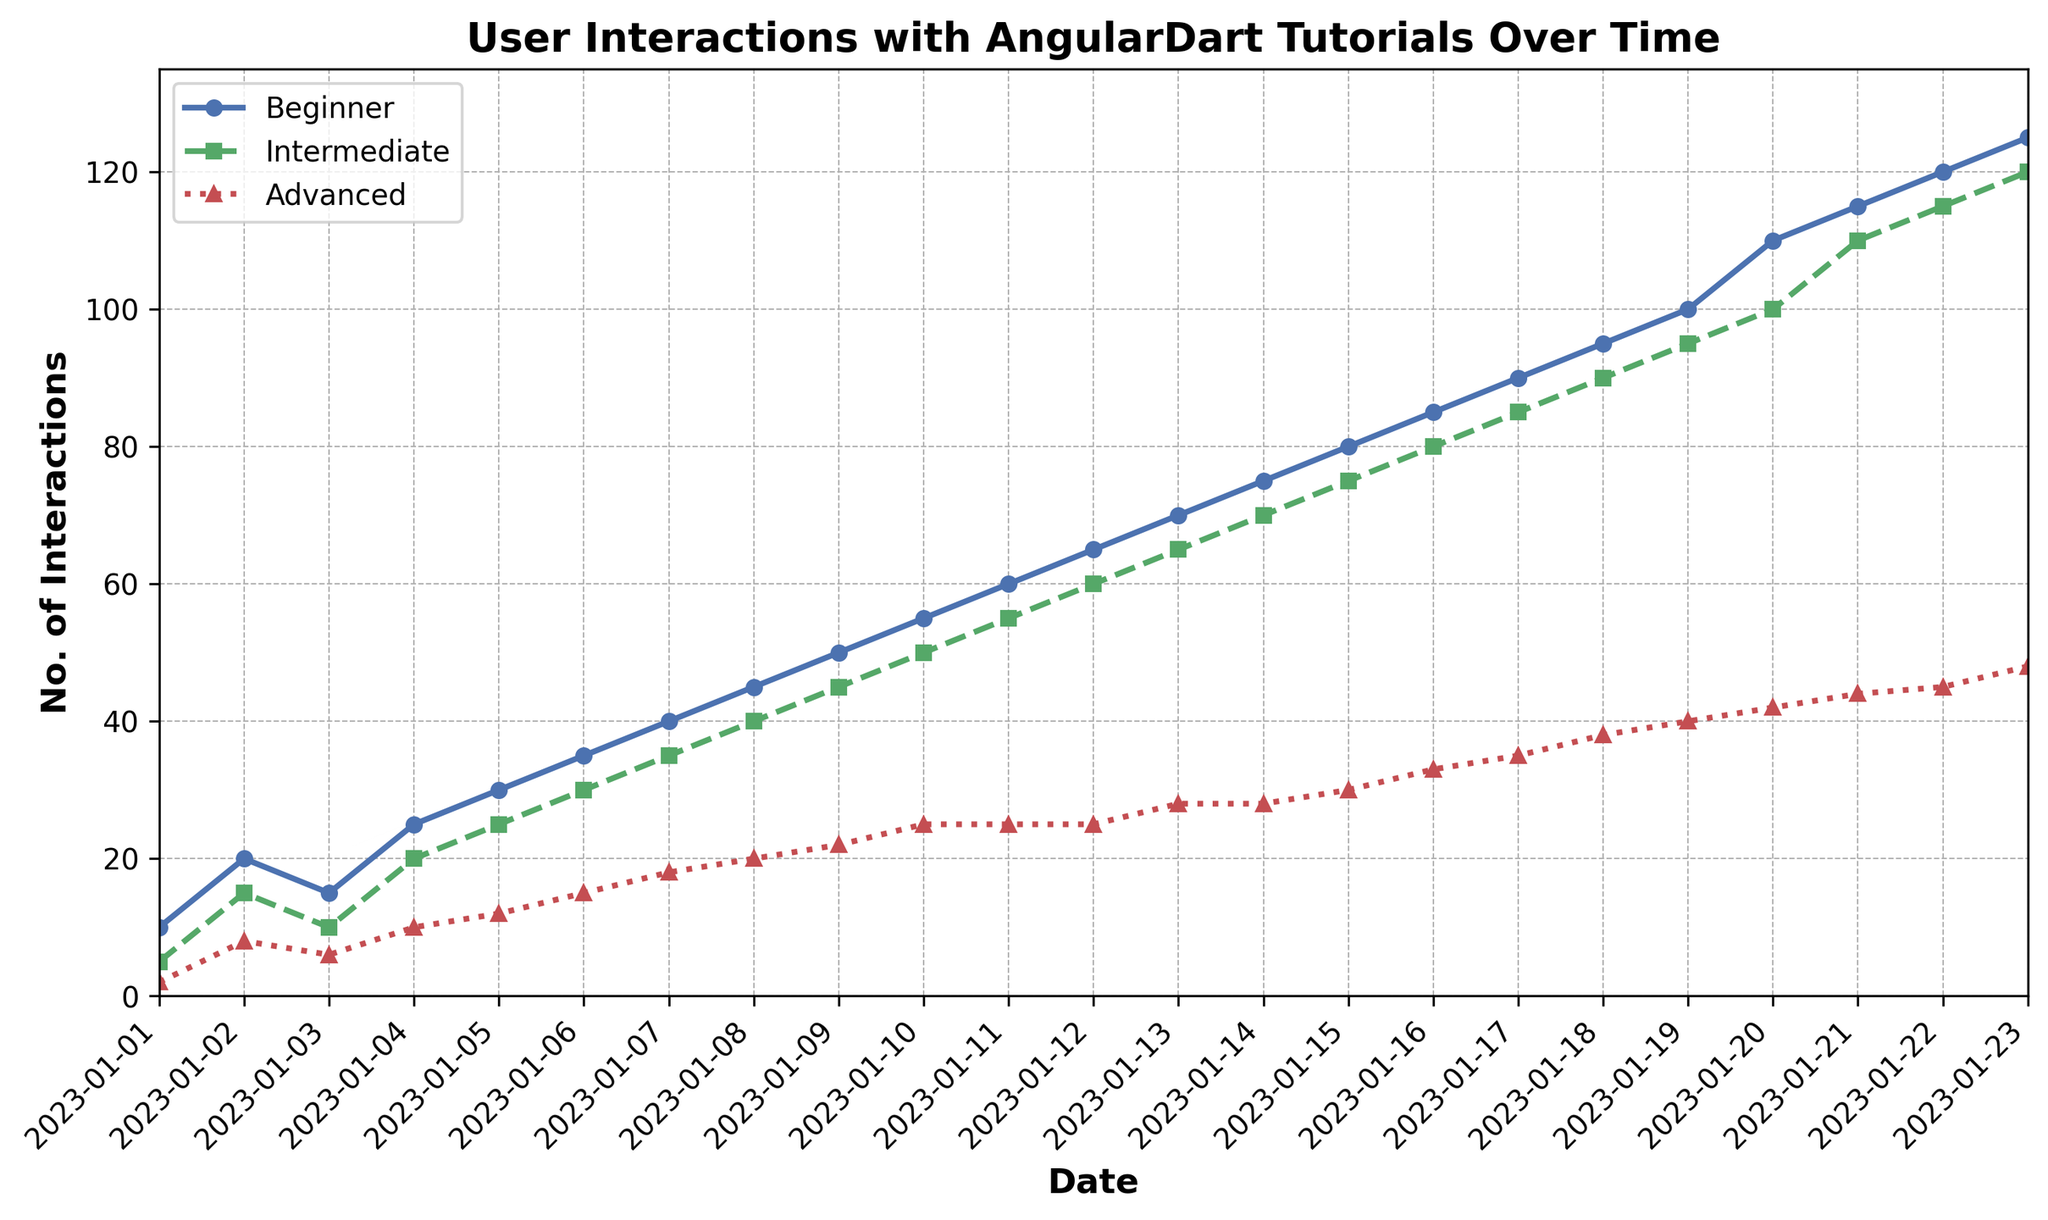What was the number of beginner interactions on January 10 compared to advanced interactions on the same day? On January 10, the chart shows that beginner interactions are represented by the blue line, and the value is 55. Advanced interactions are represented by the red line, and the value is 25. Therefore, beginner interactions are higher on this day.
Answer: Beginner interactions were higher than advanced interactions by 30 What is the total number of interactions for intermediate tutorials from January 1 to January 10? Sum the values of intermediate interactions from January 1 to January 10: 5 + 15 + 10 + 20 + 25 + 30 + 35 + 40 + 45 + 50 = 275.
Answer: 275 Which day has the highest increase in advanced interactions compared to the previous day? Analyze the difference in advanced interactions from one day to the next. The values and differences are as follows: 2→8 (+6), 8→6 (-2), 6→10 (+4), 10→12 (+2), 12→15 (+3), 15→18 (+3), 18→20 (+2), 20→22 (+2), 22→25 (+3), 25→25 (0), 25→25 (0), 25→28 (+3), 28→28 (0), 28→30 (+2), 30→33 (+3), 33→35 (+2), 35→38 (+3), 38→40 (+2), 40→42 (+2), 42→44 (+2), 44→45 (+1), 45→48 (+3). The highest increase is between January 1 and January 2 (+6).
Answer: January 2 What is the average number of beginner interactions over the entire period? First, sum the beginner interactions: (10 + 20 + 15 + 25 + 30 + 35 + 40 + 45 + 50 + 55 + 60 + 65 + 70 + 75 + 80 + 85 + 90 + 95 + 100 + 110 + 115 + 120 + 125) = 1470. Then, divide this sum by the number of days (23). 1470 / 23 ≈ 63.91.
Answer: 63.91 By how much did the number of beginner interactions surpass intermediate interactions on January 18? On January 18, beginner interactions = 95, intermediate interactions = 90. The difference is 95 - 90 = 5.
Answer: 5 On which day did the number of advanced interactions first reach 30, and what were the beginner interactions on that day? The chart shows advanced interactions reach 30 on January 15. On that day, the beginner interactions were 80.
Answer: January 15, 80 How does the trend of interactions for beginner tutorials compare with advanced tutorials over the given period? From the chart, the trend for beginner interactions shows a steady and consistent increase from 10 to 125 over the period. Advanced interactions also increase but at a slower pace, from 2 to 48. This implies that beginner interactions grow more rapidly and consistently compared to advanced interactions.
Answer: Beginner interactions grow more rapidly and consistently than advanced interactions What is the difference between the highest and lowest values for intermediate interactions over the given period? The highest value for intermediate interactions is 120 on January 23, and the lowest value is 5 on January 1. The difference is 120 - 5 = 115.
Answer: 115 